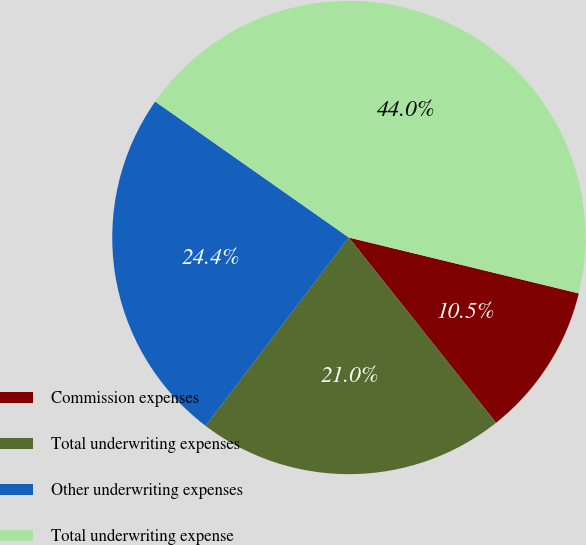Convert chart. <chart><loc_0><loc_0><loc_500><loc_500><pie_chart><fcel>Commission expenses<fcel>Total underwriting expenses<fcel>Other underwriting expenses<fcel>Total underwriting expense<nl><fcel>10.52%<fcel>21.04%<fcel>24.39%<fcel>44.05%<nl></chart> 